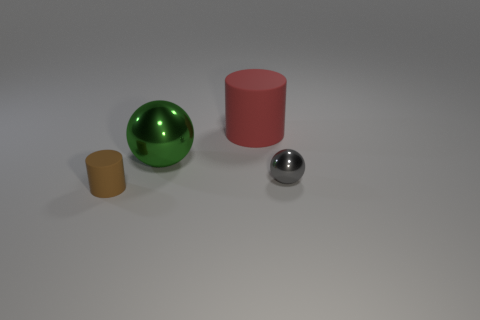Add 4 big yellow rubber blocks. How many objects exist? 8 Subtract 2 cylinders. How many cylinders are left? 0 Subtract all green spheres. Subtract all brown cylinders. How many spheres are left? 1 Subtract all blue cylinders. How many purple spheres are left? 0 Subtract all red cylinders. Subtract all green balls. How many objects are left? 2 Add 4 green shiny spheres. How many green shiny spheres are left? 5 Add 2 metal things. How many metal things exist? 4 Subtract 0 purple spheres. How many objects are left? 4 